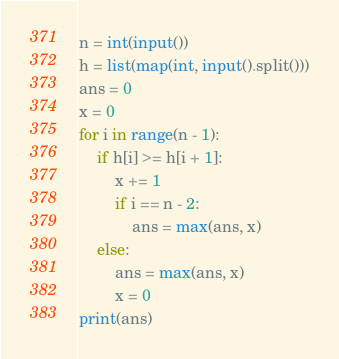Convert code to text. <code><loc_0><loc_0><loc_500><loc_500><_Python_>n = int(input())
h = list(map(int, input().split()))
ans = 0
x = 0
for i in range(n - 1):
    if h[i] >= h[i + 1]:
        x += 1
        if i == n - 2:
            ans = max(ans, x)
    else:
        ans = max(ans, x)
        x = 0
print(ans)
</code> 